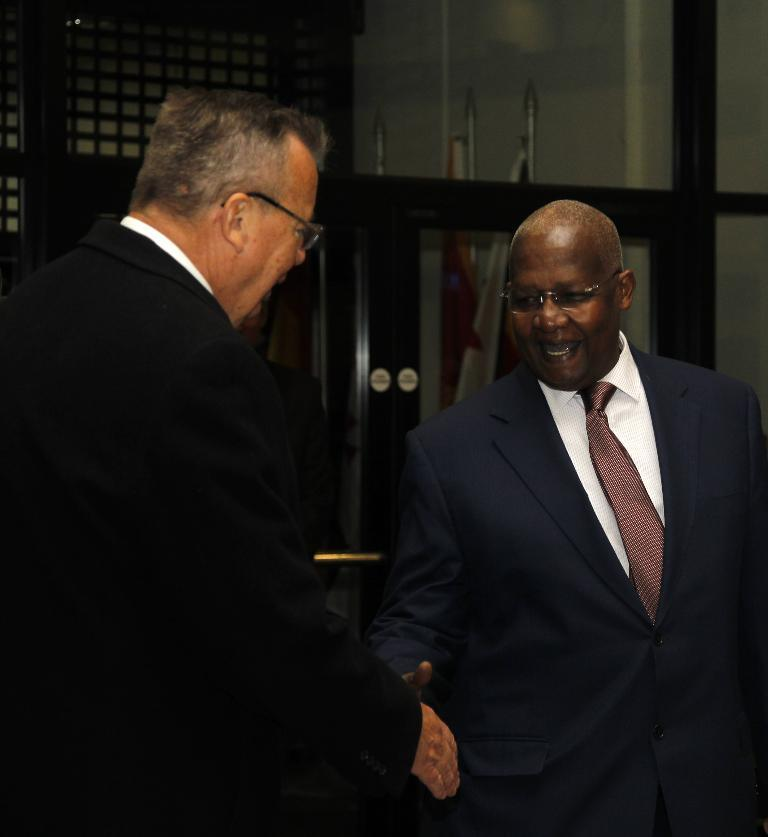How many people are present in the image? There are two people standing in the image. What are the two people doing? The two people are talking. What can be seen in the background of the image? There are flags visible in the image. How are the flags positioned in relation to the people? The flags are behind a glass wall. What month is it in the image? The month cannot be determined from the image, as there is no information about the date or time of year. What type of hair can be seen on the people in the image? The image does not provide enough detail to determine the type of hair on the people. 